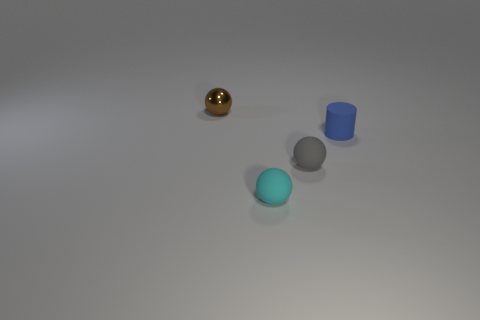Subtract all brown spheres. How many spheres are left? 2 Subtract all small brown spheres. How many spheres are left? 2 Subtract 0 cyan cylinders. How many objects are left? 4 Subtract all cylinders. How many objects are left? 3 Subtract 1 spheres. How many spheres are left? 2 Subtract all cyan balls. Subtract all green blocks. How many balls are left? 2 Subtract all green spheres. How many red cylinders are left? 0 Subtract all blue matte objects. Subtract all big red cubes. How many objects are left? 3 Add 3 spheres. How many spheres are left? 6 Add 3 large yellow shiny balls. How many large yellow shiny balls exist? 3 